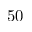<formula> <loc_0><loc_0><loc_500><loc_500>5 0</formula> 